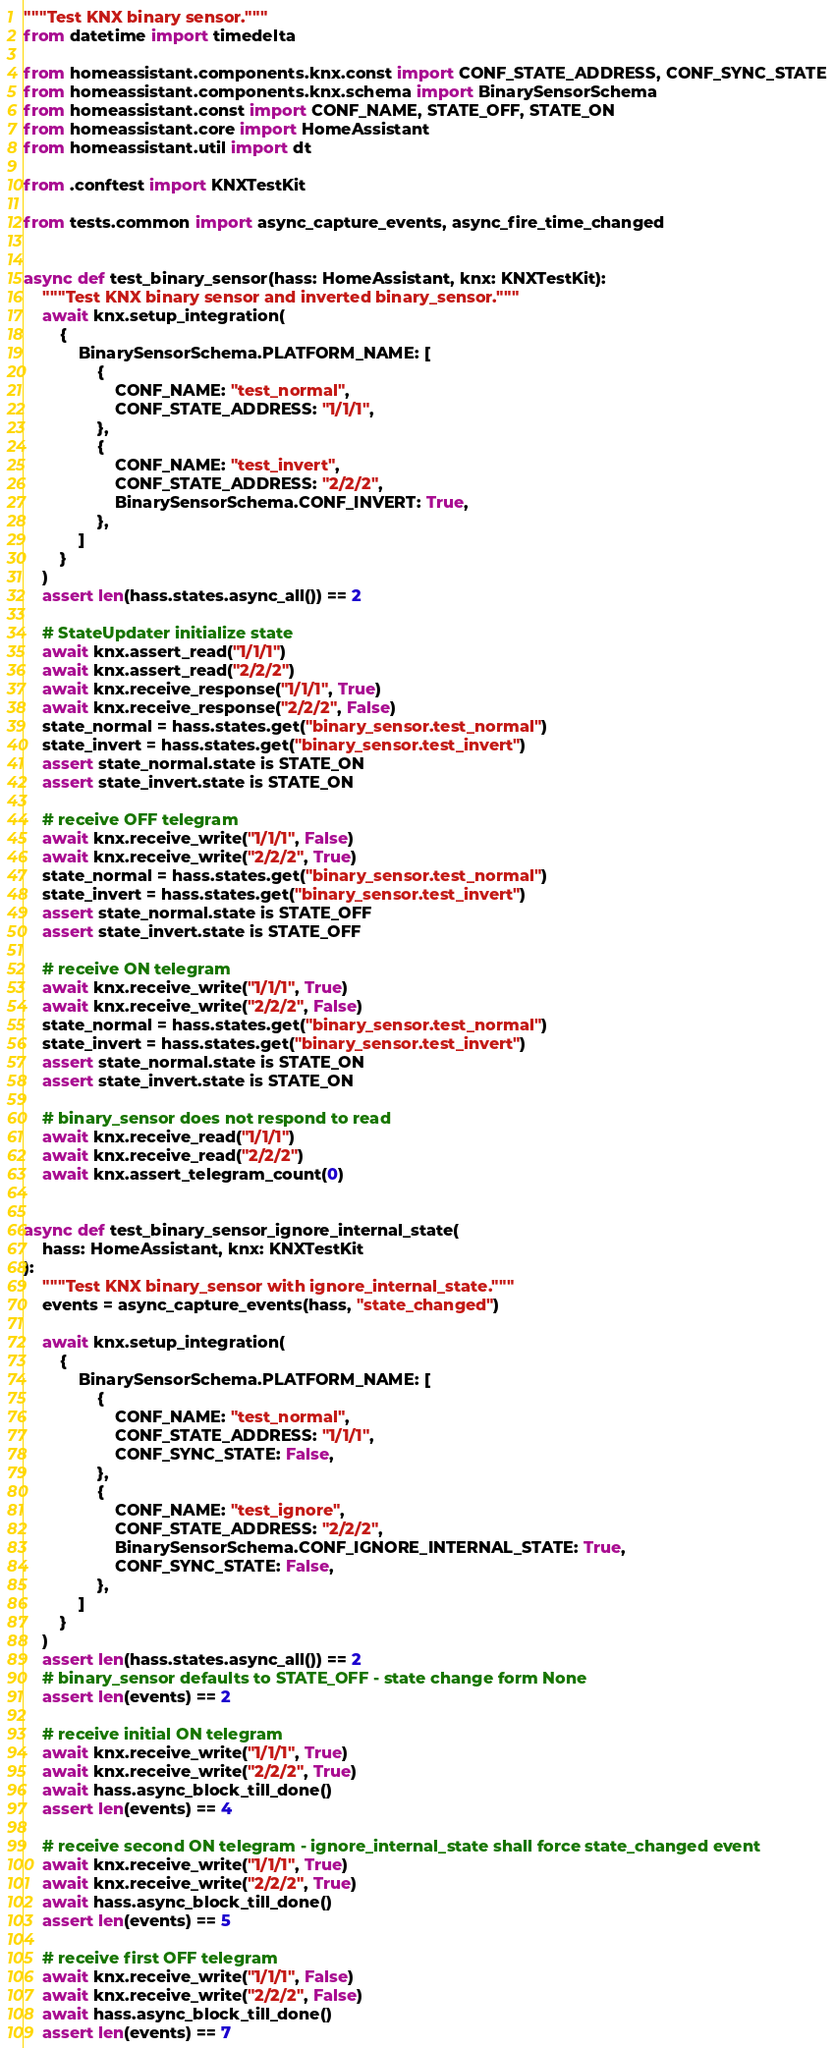Convert code to text. <code><loc_0><loc_0><loc_500><loc_500><_Python_>"""Test KNX binary sensor."""
from datetime import timedelta

from homeassistant.components.knx.const import CONF_STATE_ADDRESS, CONF_SYNC_STATE
from homeassistant.components.knx.schema import BinarySensorSchema
from homeassistant.const import CONF_NAME, STATE_OFF, STATE_ON
from homeassistant.core import HomeAssistant
from homeassistant.util import dt

from .conftest import KNXTestKit

from tests.common import async_capture_events, async_fire_time_changed


async def test_binary_sensor(hass: HomeAssistant, knx: KNXTestKit):
    """Test KNX binary sensor and inverted binary_sensor."""
    await knx.setup_integration(
        {
            BinarySensorSchema.PLATFORM_NAME: [
                {
                    CONF_NAME: "test_normal",
                    CONF_STATE_ADDRESS: "1/1/1",
                },
                {
                    CONF_NAME: "test_invert",
                    CONF_STATE_ADDRESS: "2/2/2",
                    BinarySensorSchema.CONF_INVERT: True,
                },
            ]
        }
    )
    assert len(hass.states.async_all()) == 2

    # StateUpdater initialize state
    await knx.assert_read("1/1/1")
    await knx.assert_read("2/2/2")
    await knx.receive_response("1/1/1", True)
    await knx.receive_response("2/2/2", False)
    state_normal = hass.states.get("binary_sensor.test_normal")
    state_invert = hass.states.get("binary_sensor.test_invert")
    assert state_normal.state is STATE_ON
    assert state_invert.state is STATE_ON

    # receive OFF telegram
    await knx.receive_write("1/1/1", False)
    await knx.receive_write("2/2/2", True)
    state_normal = hass.states.get("binary_sensor.test_normal")
    state_invert = hass.states.get("binary_sensor.test_invert")
    assert state_normal.state is STATE_OFF
    assert state_invert.state is STATE_OFF

    # receive ON telegram
    await knx.receive_write("1/1/1", True)
    await knx.receive_write("2/2/2", False)
    state_normal = hass.states.get("binary_sensor.test_normal")
    state_invert = hass.states.get("binary_sensor.test_invert")
    assert state_normal.state is STATE_ON
    assert state_invert.state is STATE_ON

    # binary_sensor does not respond to read
    await knx.receive_read("1/1/1")
    await knx.receive_read("2/2/2")
    await knx.assert_telegram_count(0)


async def test_binary_sensor_ignore_internal_state(
    hass: HomeAssistant, knx: KNXTestKit
):
    """Test KNX binary_sensor with ignore_internal_state."""
    events = async_capture_events(hass, "state_changed")

    await knx.setup_integration(
        {
            BinarySensorSchema.PLATFORM_NAME: [
                {
                    CONF_NAME: "test_normal",
                    CONF_STATE_ADDRESS: "1/1/1",
                    CONF_SYNC_STATE: False,
                },
                {
                    CONF_NAME: "test_ignore",
                    CONF_STATE_ADDRESS: "2/2/2",
                    BinarySensorSchema.CONF_IGNORE_INTERNAL_STATE: True,
                    CONF_SYNC_STATE: False,
                },
            ]
        }
    )
    assert len(hass.states.async_all()) == 2
    # binary_sensor defaults to STATE_OFF - state change form None
    assert len(events) == 2

    # receive initial ON telegram
    await knx.receive_write("1/1/1", True)
    await knx.receive_write("2/2/2", True)
    await hass.async_block_till_done()
    assert len(events) == 4

    # receive second ON telegram - ignore_internal_state shall force state_changed event
    await knx.receive_write("1/1/1", True)
    await knx.receive_write("2/2/2", True)
    await hass.async_block_till_done()
    assert len(events) == 5

    # receive first OFF telegram
    await knx.receive_write("1/1/1", False)
    await knx.receive_write("2/2/2", False)
    await hass.async_block_till_done()
    assert len(events) == 7
</code> 